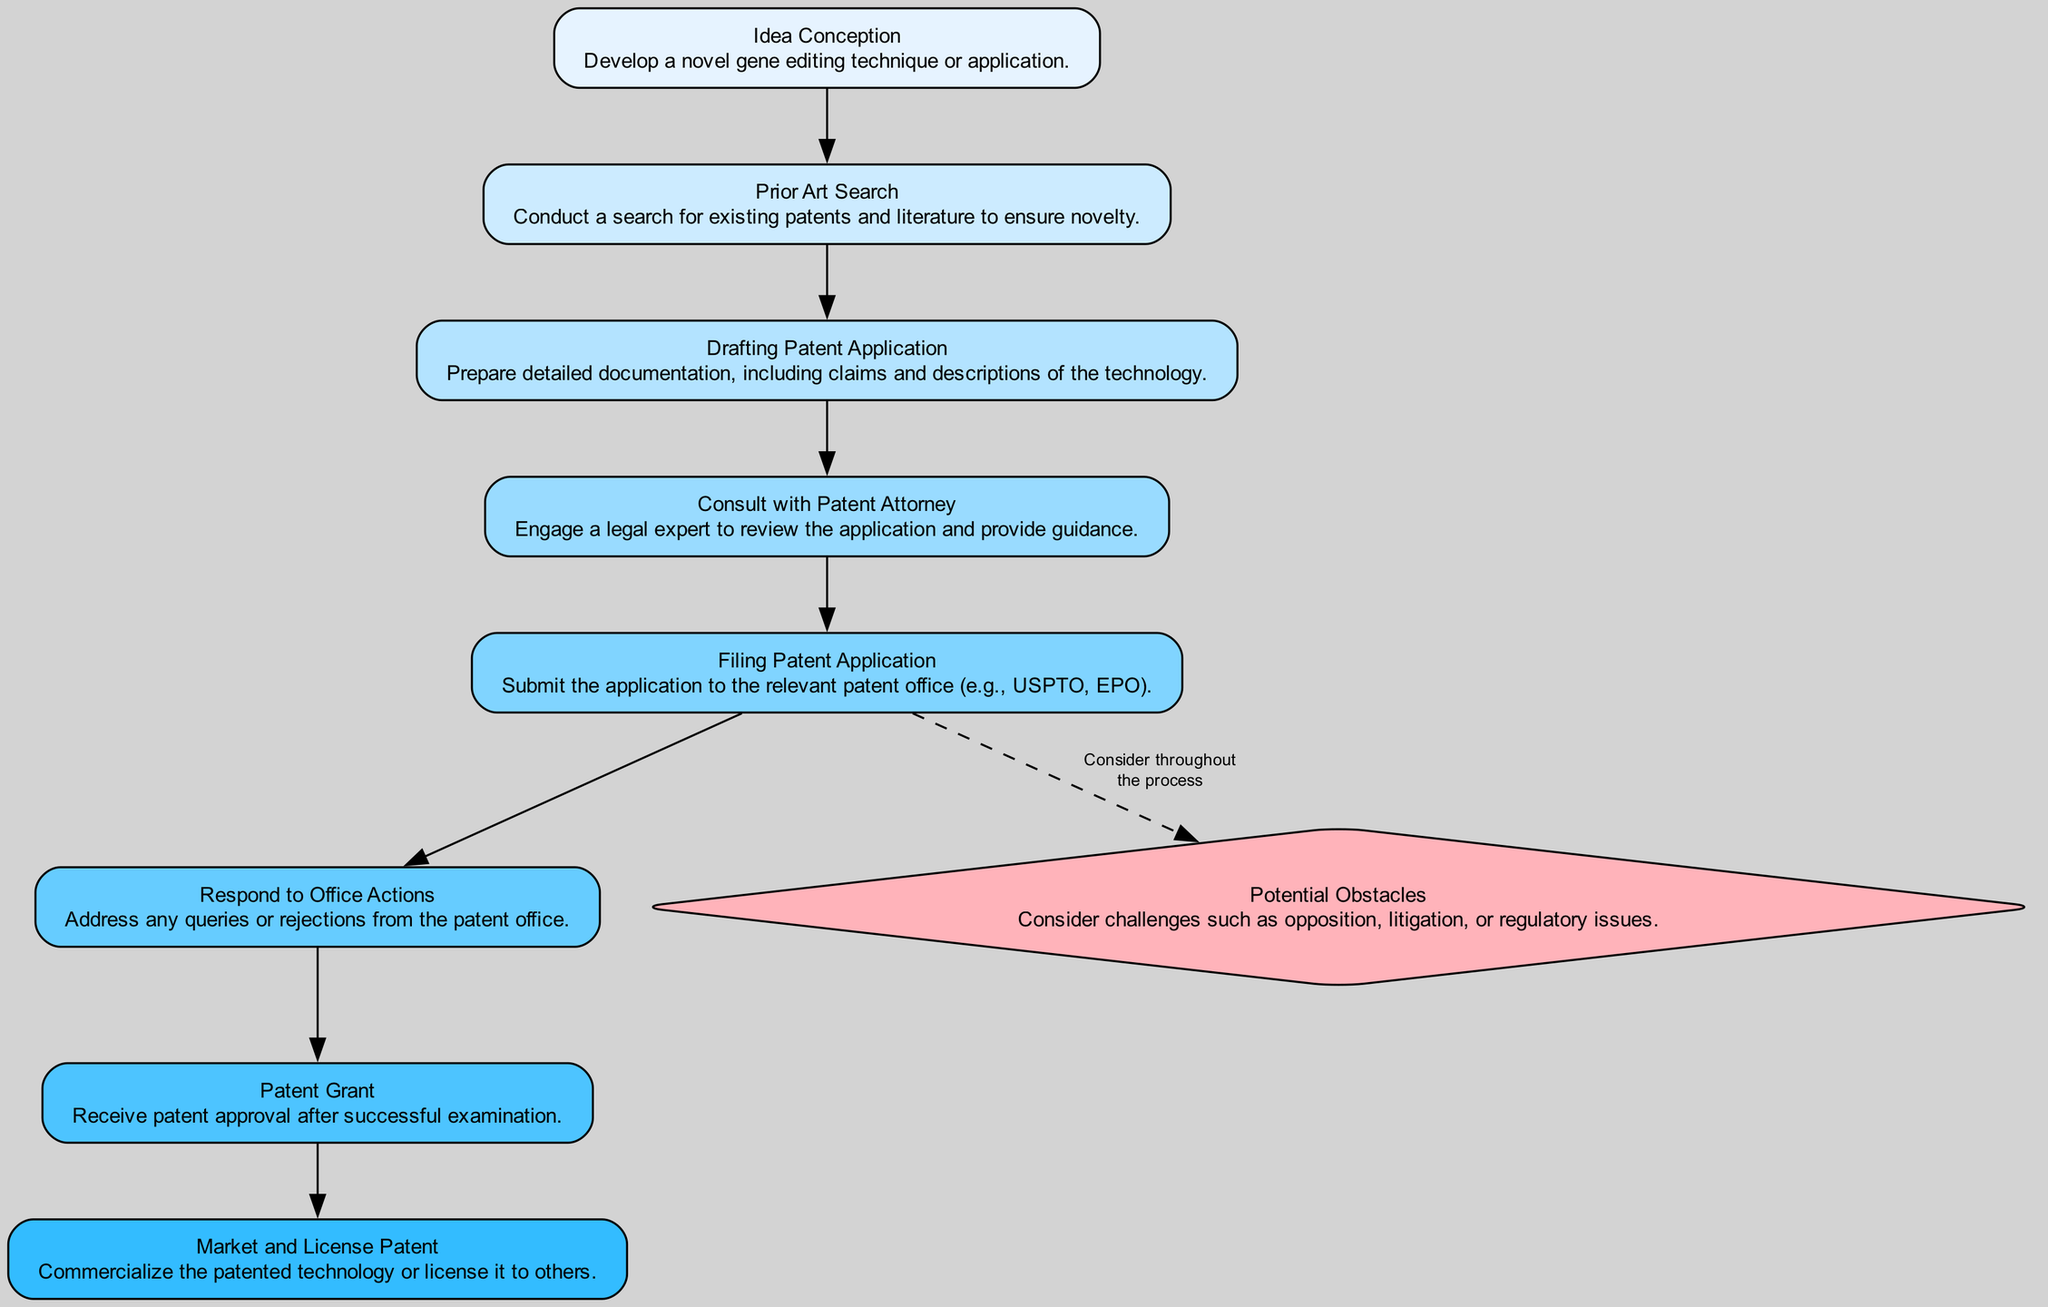What is the last step in the flow chart? The last step in the flow chart is "Market and License Patent." It is the final node after the "Patent Grant" step indicating commercialization of the patented technology.
Answer: Market and License Patent How many total steps are presented in this diagram? The diagram includes a total of nine steps. Each step is represented as a node in the flow chart.
Answer: Nine What step follows "Drafting Patent Application"? The step that follows "Drafting Patent Application" is "Consult with Patent Attorney." This is the immediate next step indicating legal consultation.
Answer: Consult with Patent Attorney Which step is color-coded differently and why? The step "Potential Obstacles" is color-coded differently (in red) because it is a diamond-shaped node, indicating its special importance and that it should be considered throughout the process.
Answer: Potential Obstacles What step comes immediately before "Filing Patent Application"? The step that comes immediately before "Filing Patent Application" is "Consult with Patent Attorney." This indicates that legal guidance is sought before filing the application.
Answer: Consult with Patent Attorney What is the connection between "Patent Grant" and "Market and License Patent"? "Patent Grant" leads to "Market and License Patent," indicating that after patent approval, the next step is to commercialize or license the technology.
Answer: Market and License Patent What is the main purpose of the "Prior Art Search"? The main purpose of the "Prior Art Search" is to ensure novelty by checking for existing patents and literature. This is essential to determine if the new invention is patentable.
Answer: Ensure novelty What distinguishes "Potential Obstacles" from other steps? "Potential Obstacles" is distinguished by its diamond shape and different color, indicating that it outlines challenges that could arise throughout the patenting process.
Answer: Challenges through the process What action is taken in "Respond to Office Actions"? In "Respond to Office Actions," the action involves addressing any queries or rejections received from the patent office. This is a critical step in the application process.
Answer: Address queries or rejections 